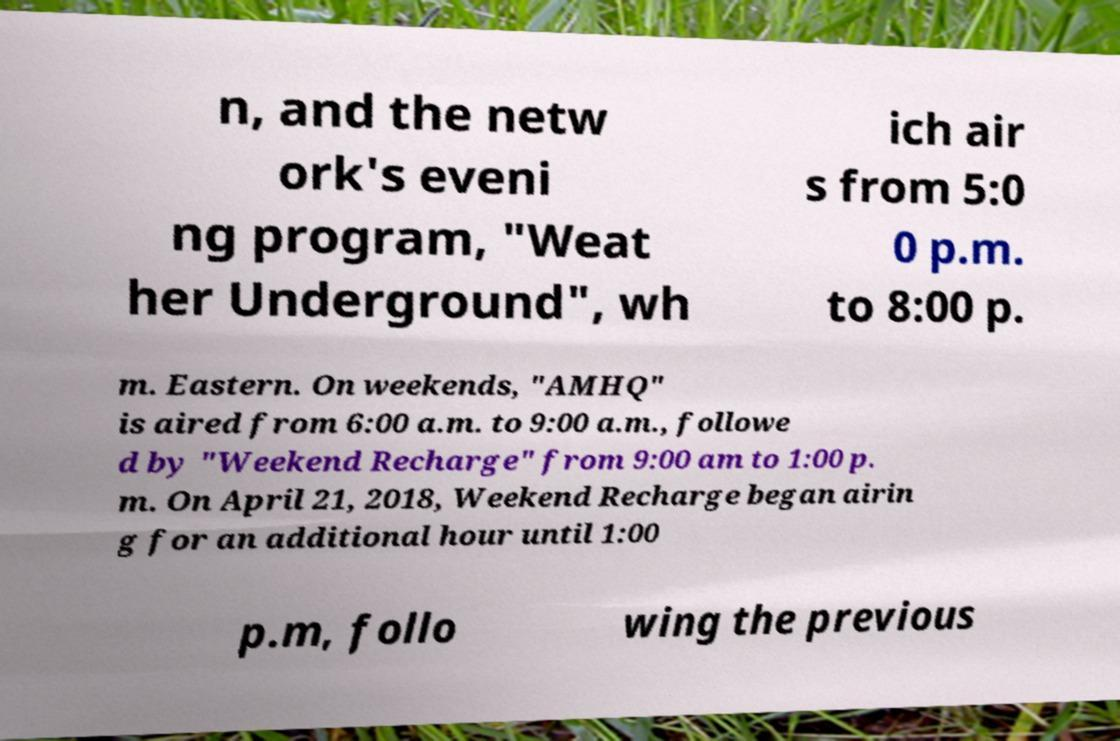For documentation purposes, I need the text within this image transcribed. Could you provide that? n, and the netw ork's eveni ng program, "Weat her Underground", wh ich air s from 5:0 0 p.m. to 8:00 p. m. Eastern. On weekends, "AMHQ" is aired from 6:00 a.m. to 9:00 a.m., followe d by "Weekend Recharge" from 9:00 am to 1:00 p. m. On April 21, 2018, Weekend Recharge began airin g for an additional hour until 1:00 p.m, follo wing the previous 